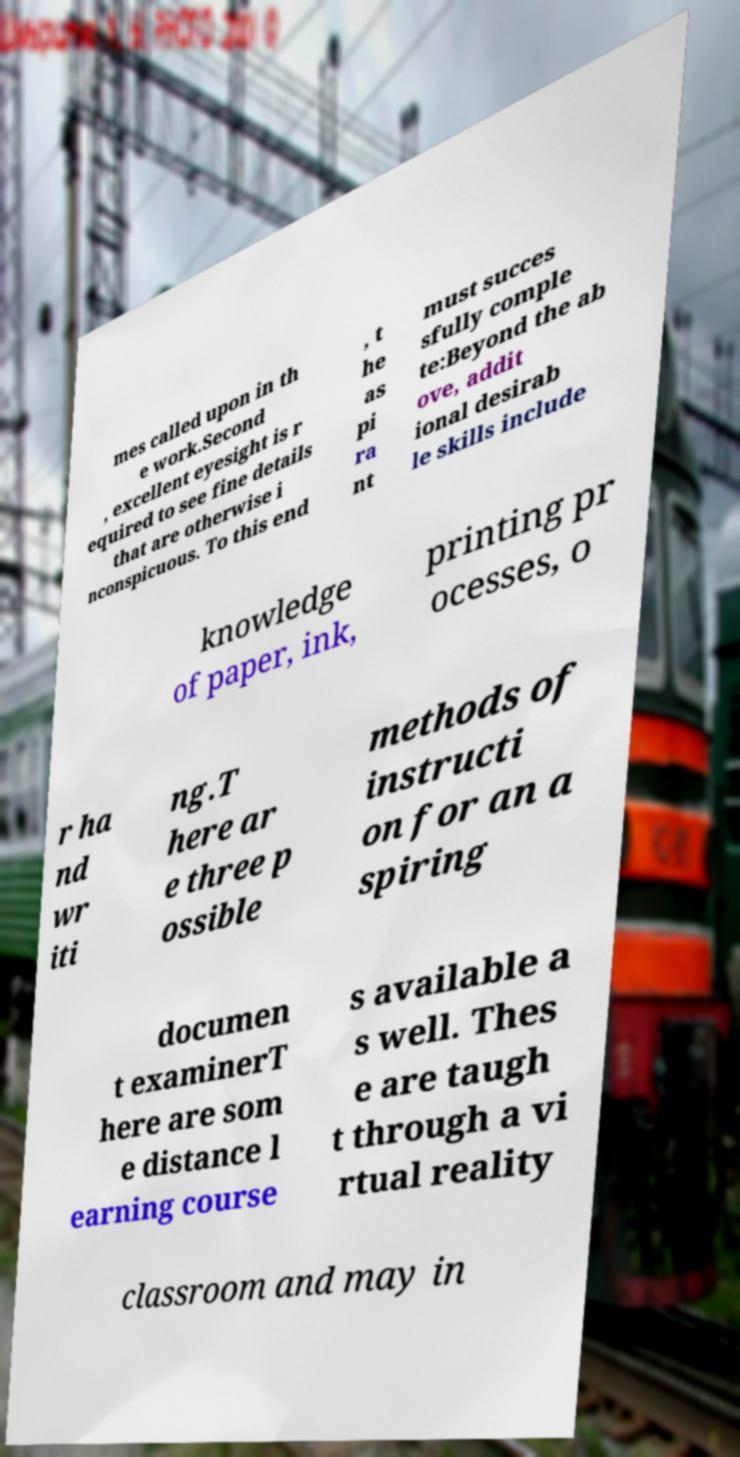There's text embedded in this image that I need extracted. Can you transcribe it verbatim? mes called upon in th e work.Second , excellent eyesight is r equired to see fine details that are otherwise i nconspicuous. To this end , t he as pi ra nt must succes sfully comple te:Beyond the ab ove, addit ional desirab le skills include knowledge of paper, ink, printing pr ocesses, o r ha nd wr iti ng.T here ar e three p ossible methods of instructi on for an a spiring documen t examinerT here are som e distance l earning course s available a s well. Thes e are taugh t through a vi rtual reality classroom and may in 